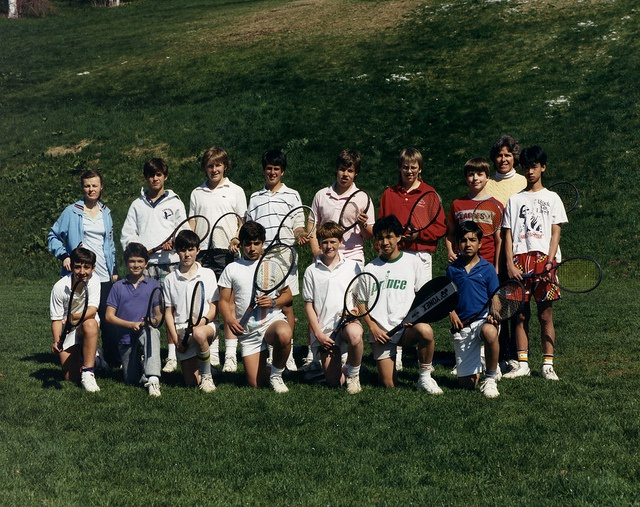Describe the objects in this image and their specific colors. I can see people in black, lightgray, gray, and navy tones, people in black, lightgray, brown, and maroon tones, people in black, lightgray, gray, and darkgray tones, people in black, lightgray, darkgray, and gray tones, and people in black, lightgray, gray, and darkgray tones in this image. 